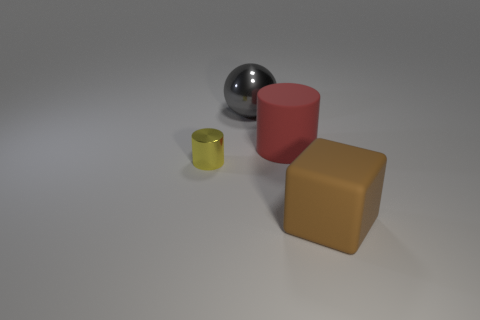What number of things are either metal things that are in front of the large gray shiny sphere or metallic objects in front of the red rubber cylinder?
Give a very brief answer. 1. There is a object that is to the right of the big red cylinder; is its size the same as the metallic thing that is behind the large red matte cylinder?
Provide a succinct answer. Yes. The metal object that is the same shape as the red rubber object is what color?
Offer a very short reply. Yellow. Are there any other things that are the same shape as the gray metallic thing?
Offer a terse response. No. Is the number of matte cylinders that are in front of the large red rubber cylinder greater than the number of red matte things that are on the right side of the tiny thing?
Provide a succinct answer. No. There is a cylinder left of the shiny thing that is to the right of the shiny thing that is in front of the big cylinder; what is its size?
Provide a succinct answer. Small. Are the big gray sphere and the cylinder to the left of the gray ball made of the same material?
Ensure brevity in your answer.  Yes. Do the large gray metal thing and the big red object have the same shape?
Your response must be concise. No. What number of other objects are the same material as the big brown block?
Make the answer very short. 1. What number of large red matte things have the same shape as the tiny metallic object?
Provide a succinct answer. 1. 